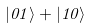<formula> <loc_0><loc_0><loc_500><loc_500>| 0 1 \rangle + | 1 0 \rangle</formula> 